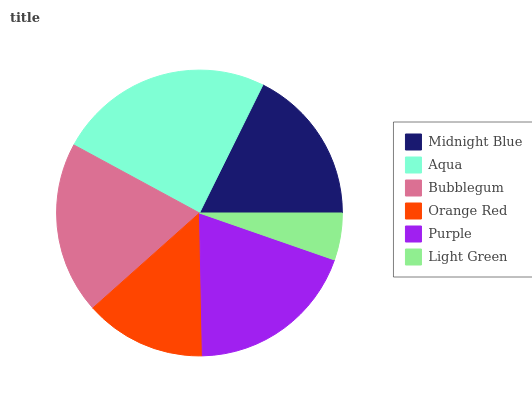Is Light Green the minimum?
Answer yes or no. Yes. Is Aqua the maximum?
Answer yes or no. Yes. Is Bubblegum the minimum?
Answer yes or no. No. Is Bubblegum the maximum?
Answer yes or no. No. Is Aqua greater than Bubblegum?
Answer yes or no. Yes. Is Bubblegum less than Aqua?
Answer yes or no. Yes. Is Bubblegum greater than Aqua?
Answer yes or no. No. Is Aqua less than Bubblegum?
Answer yes or no. No. Is Purple the high median?
Answer yes or no. Yes. Is Midnight Blue the low median?
Answer yes or no. Yes. Is Light Green the high median?
Answer yes or no. No. Is Orange Red the low median?
Answer yes or no. No. 